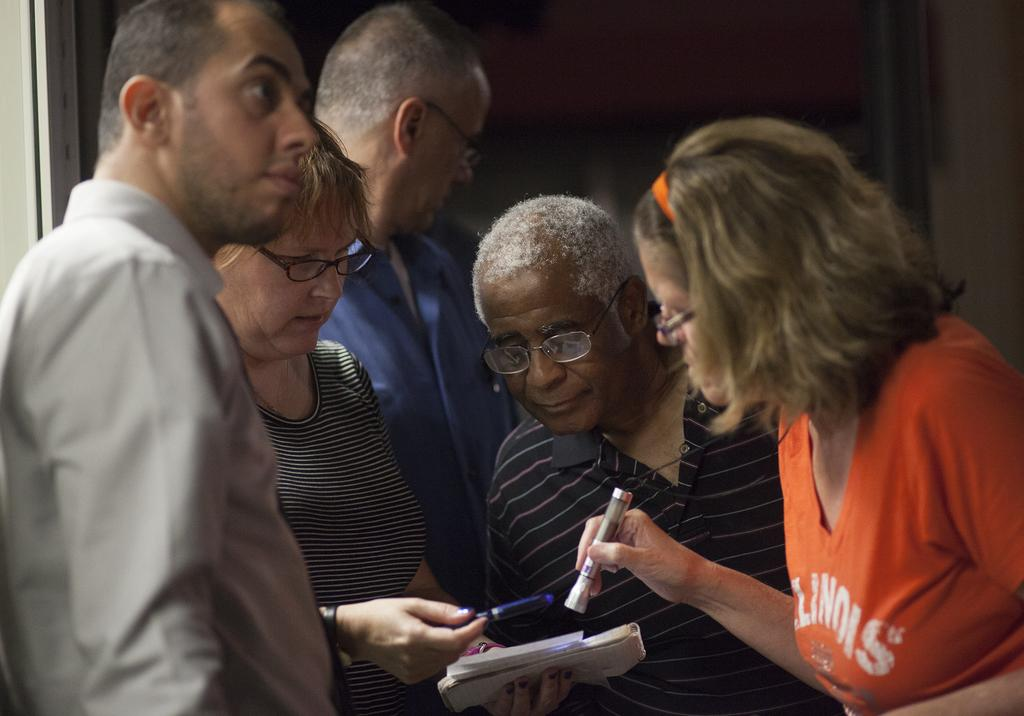How many people are in the image? There are five persons in the image. What do all the persons in the image have in common? All five persons are wearing spectacles. What is one person doing with her hands? One person is holding a pen and a book with her hands. What is the color of the background in the image? The background of the image is dark. What type of finger can be seen pointing at an angle in the image? There is no finger pointing at an angle in the image. What line can be seen connecting the five persons in the image? There is no line connecting the five persons in the image. 